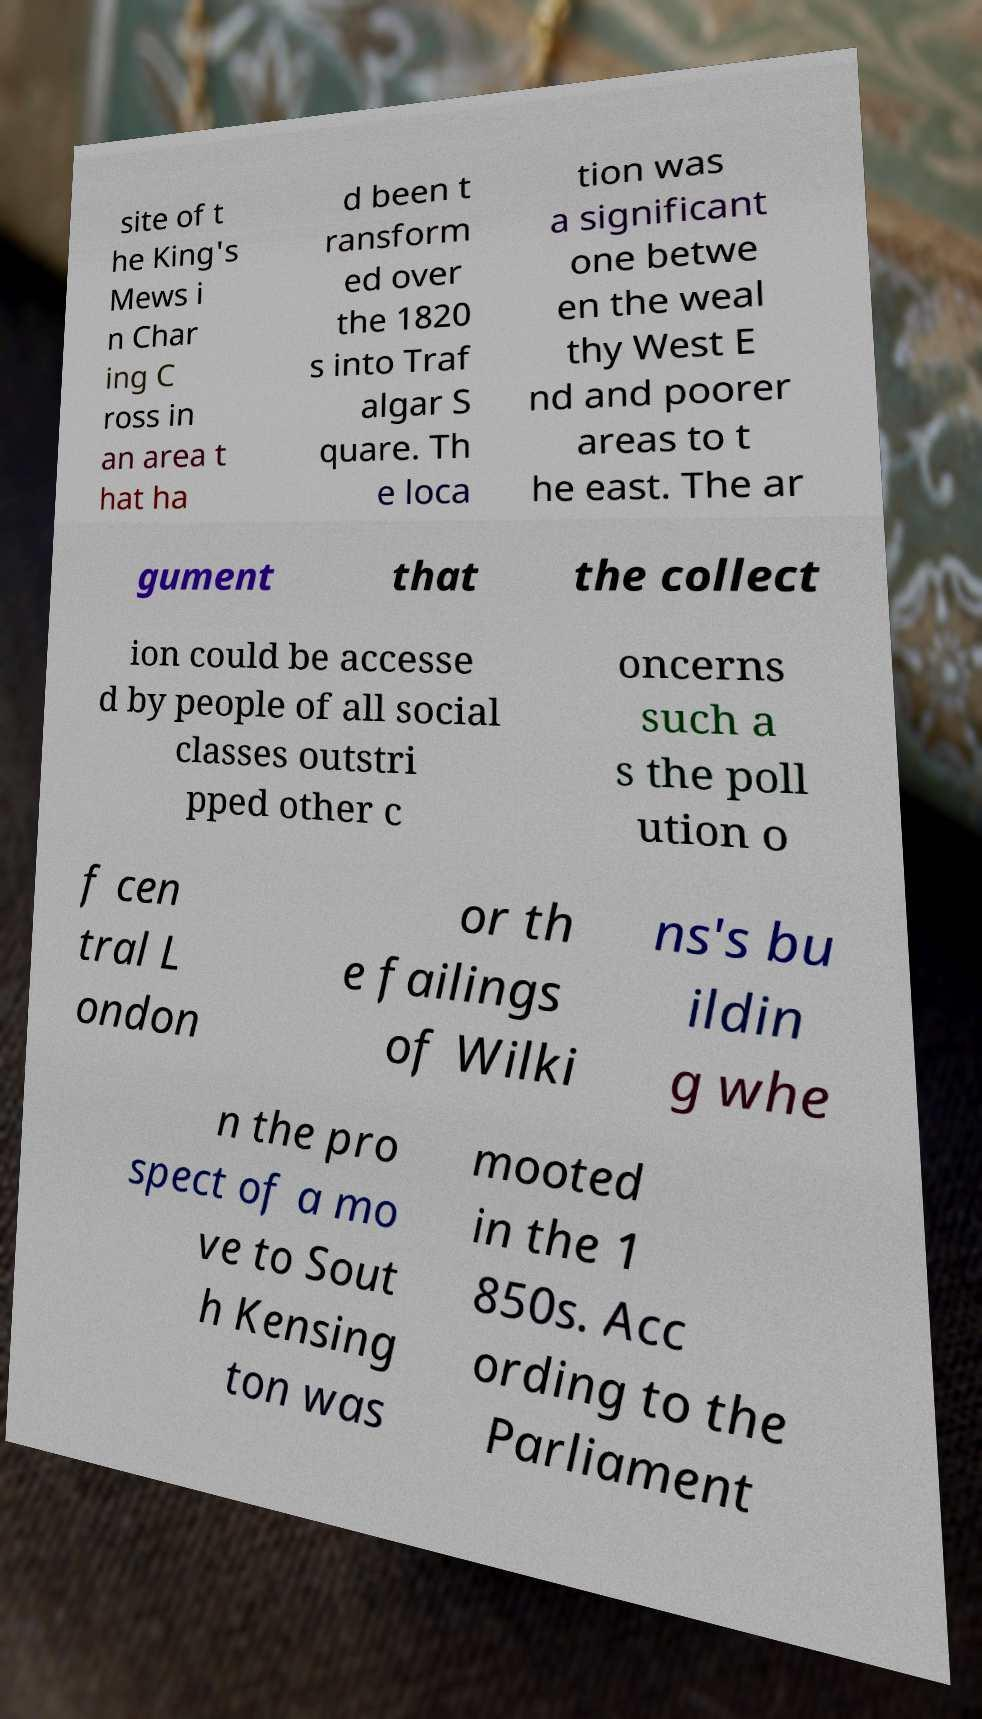Could you extract and type out the text from this image? site of t he King's Mews i n Char ing C ross in an area t hat ha d been t ransform ed over the 1820 s into Traf algar S quare. Th e loca tion was a significant one betwe en the weal thy West E nd and poorer areas to t he east. The ar gument that the collect ion could be accesse d by people of all social classes outstri pped other c oncerns such a s the poll ution o f cen tral L ondon or th e failings of Wilki ns's bu ildin g whe n the pro spect of a mo ve to Sout h Kensing ton was mooted in the 1 850s. Acc ording to the Parliament 